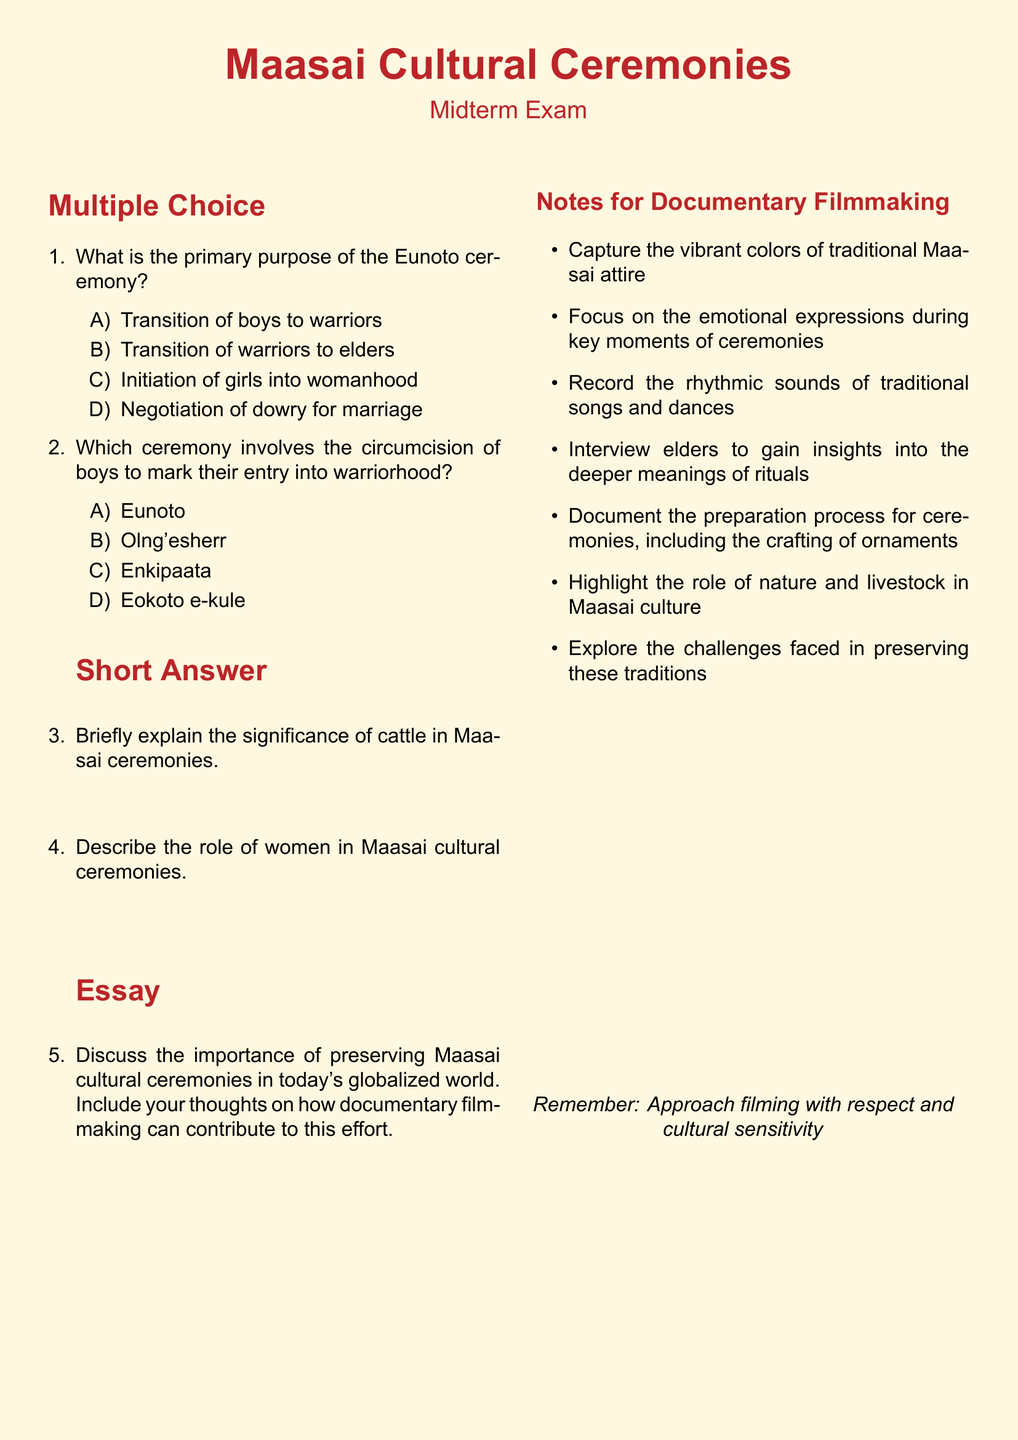What is the primary purpose of the Eunoto ceremony? The Eunoto ceremony primarily signifies the transition of boys to warriors as described in the multiple-choice section.
Answer: Transition of boys to warriors Which ceremony involves the circumcision of boys? The ceremony that marks the entry of boys into warriorhood through circumcision is specified as Enkipaata in the document.
Answer: Enkipaata How many sections are there in the midterm exam? The midterm exam contains three sections: Multiple Choice, Short Answer, and Essay.
Answer: Three What color is used for the main text in the header? The document uses maasaiRed for the main text color in the header.
Answer: maasaiRed What is the suggested focus for documentary filmmakers capturing Maasai ceremonies? The document highlights the importance of capturing emotional expressions during key moments of ceremonies as a focus area for filmmakers.
Answer: Emotional expressions What should filmmakers highlight about nature in Maasai culture? Filmmakers are advised to highlight the role of nature and livestock in Maasai culture as stated in the notes section.
Answer: Nature and livestock What does the document remind filmmakers to approach filming with? The document emphasizes the need to approach filming with respect and cultural sensitivity as a crucial guideline.
Answer: Respect and cultural sensitivity What is one role of women in Maasai cultural ceremonies? The document prompts an explanation but does not provide a specific answer, thus requiring the reader to reflect on women's roles, such as caregivers or participants.
Answer: Caregivers (or participants) What is one key aspect of documenting the preparation process for ceremonies? The document emphasizes the importance of documenting the crafting of ornaments during the preparation process for ceremonies.
Answer: Crafting of ornaments 